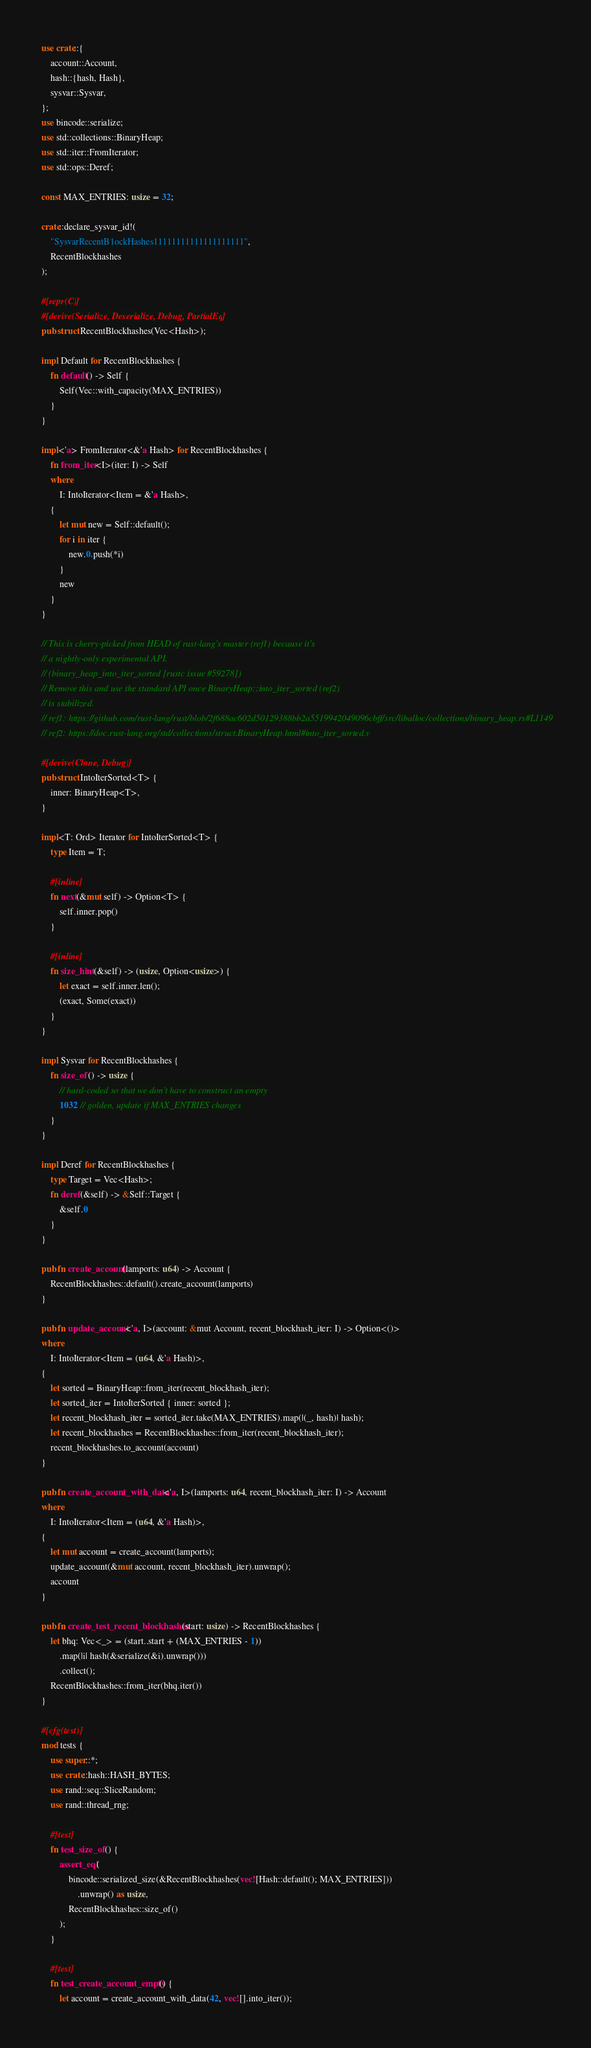Convert code to text. <code><loc_0><loc_0><loc_500><loc_500><_Rust_>use crate::{
    account::Account,
    hash::{hash, Hash},
    sysvar::Sysvar,
};
use bincode::serialize;
use std::collections::BinaryHeap;
use std::iter::FromIterator;
use std::ops::Deref;

const MAX_ENTRIES: usize = 32;

crate::declare_sysvar_id!(
    "SysvarRecentB1ockHashes11111111111111111111",
    RecentBlockhashes
);

#[repr(C)]
#[derive(Serialize, Deserialize, Debug, PartialEq)]
pub struct RecentBlockhashes(Vec<Hash>);

impl Default for RecentBlockhashes {
    fn default() -> Self {
        Self(Vec::with_capacity(MAX_ENTRIES))
    }
}

impl<'a> FromIterator<&'a Hash> for RecentBlockhashes {
    fn from_iter<I>(iter: I) -> Self
    where
        I: IntoIterator<Item = &'a Hash>,
    {
        let mut new = Self::default();
        for i in iter {
            new.0.push(*i)
        }
        new
    }
}

// This is cherry-picked from HEAD of rust-lang's master (ref1) because it's
// a nightly-only experimental API.
// (binary_heap_into_iter_sorted [rustc issue #59278])
// Remove this and use the standard API once BinaryHeap::into_iter_sorted (ref2)
// is stabilized.
// ref1: https://github.com/rust-lang/rust/blob/2f688ac602d50129388bb2a5519942049096cbff/src/liballoc/collections/binary_heap.rs#L1149
// ref2: https://doc.rust-lang.org/std/collections/struct.BinaryHeap.html#into_iter_sorted.v

#[derive(Clone, Debug)]
pub struct IntoIterSorted<T> {
    inner: BinaryHeap<T>,
}

impl<T: Ord> Iterator for IntoIterSorted<T> {
    type Item = T;

    #[inline]
    fn next(&mut self) -> Option<T> {
        self.inner.pop()
    }

    #[inline]
    fn size_hint(&self) -> (usize, Option<usize>) {
        let exact = self.inner.len();
        (exact, Some(exact))
    }
}

impl Sysvar for RecentBlockhashes {
    fn size_of() -> usize {
        // hard-coded so that we don't have to construct an empty
        1032 // golden, update if MAX_ENTRIES changes
    }
}

impl Deref for RecentBlockhashes {
    type Target = Vec<Hash>;
    fn deref(&self) -> &Self::Target {
        &self.0
    }
}

pub fn create_account(lamports: u64) -> Account {
    RecentBlockhashes::default().create_account(lamports)
}

pub fn update_account<'a, I>(account: &mut Account, recent_blockhash_iter: I) -> Option<()>
where
    I: IntoIterator<Item = (u64, &'a Hash)>,
{
    let sorted = BinaryHeap::from_iter(recent_blockhash_iter);
    let sorted_iter = IntoIterSorted { inner: sorted };
    let recent_blockhash_iter = sorted_iter.take(MAX_ENTRIES).map(|(_, hash)| hash);
    let recent_blockhashes = RecentBlockhashes::from_iter(recent_blockhash_iter);
    recent_blockhashes.to_account(account)
}

pub fn create_account_with_data<'a, I>(lamports: u64, recent_blockhash_iter: I) -> Account
where
    I: IntoIterator<Item = (u64, &'a Hash)>,
{
    let mut account = create_account(lamports);
    update_account(&mut account, recent_blockhash_iter).unwrap();
    account
}

pub fn create_test_recent_blockhashes(start: usize) -> RecentBlockhashes {
    let bhq: Vec<_> = (start..start + (MAX_ENTRIES - 1))
        .map(|i| hash(&serialize(&i).unwrap()))
        .collect();
    RecentBlockhashes::from_iter(bhq.iter())
}

#[cfg(test)]
mod tests {
    use super::*;
    use crate::hash::HASH_BYTES;
    use rand::seq::SliceRandom;
    use rand::thread_rng;

    #[test]
    fn test_size_of() {
        assert_eq!(
            bincode::serialized_size(&RecentBlockhashes(vec![Hash::default(); MAX_ENTRIES]))
                .unwrap() as usize,
            RecentBlockhashes::size_of()
        );
    }

    #[test]
    fn test_create_account_empty() {
        let account = create_account_with_data(42, vec![].into_iter());</code> 